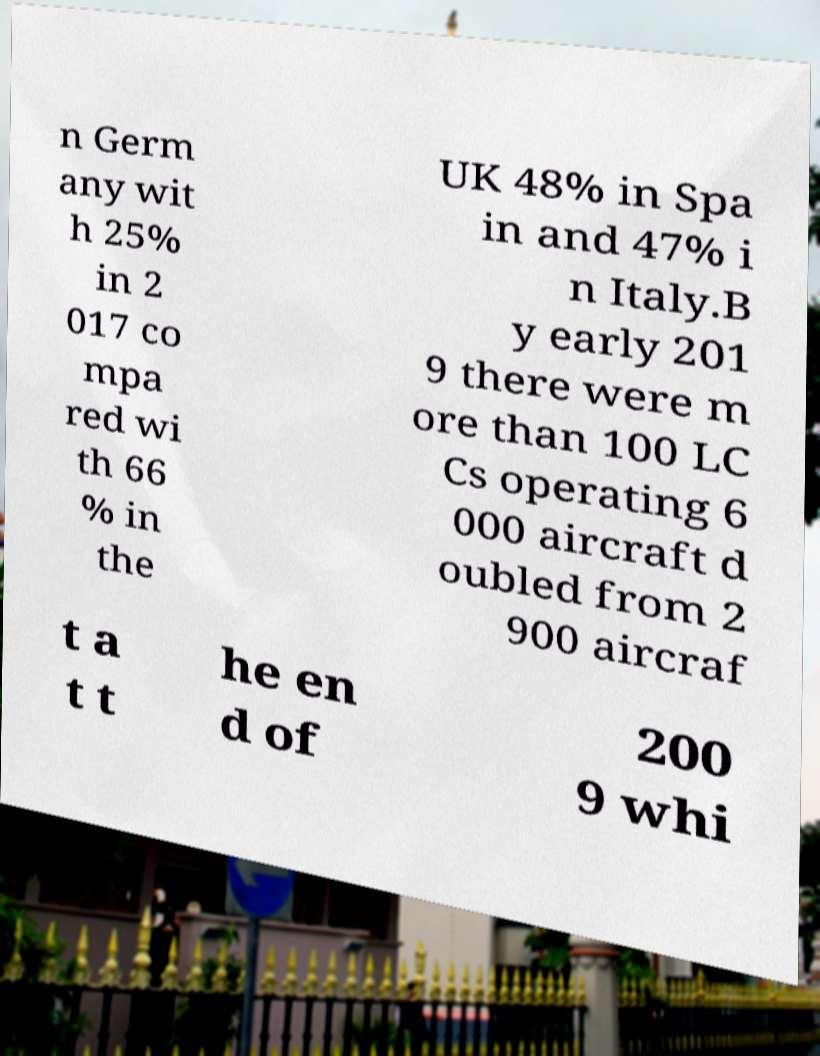Please identify and transcribe the text found in this image. n Germ any wit h 25% in 2 017 co mpa red wi th 66 % in the UK 48% in Spa in and 47% i n Italy.B y early 201 9 there were m ore than 100 LC Cs operating 6 000 aircraft d oubled from 2 900 aircraf t a t t he en d of 200 9 whi 